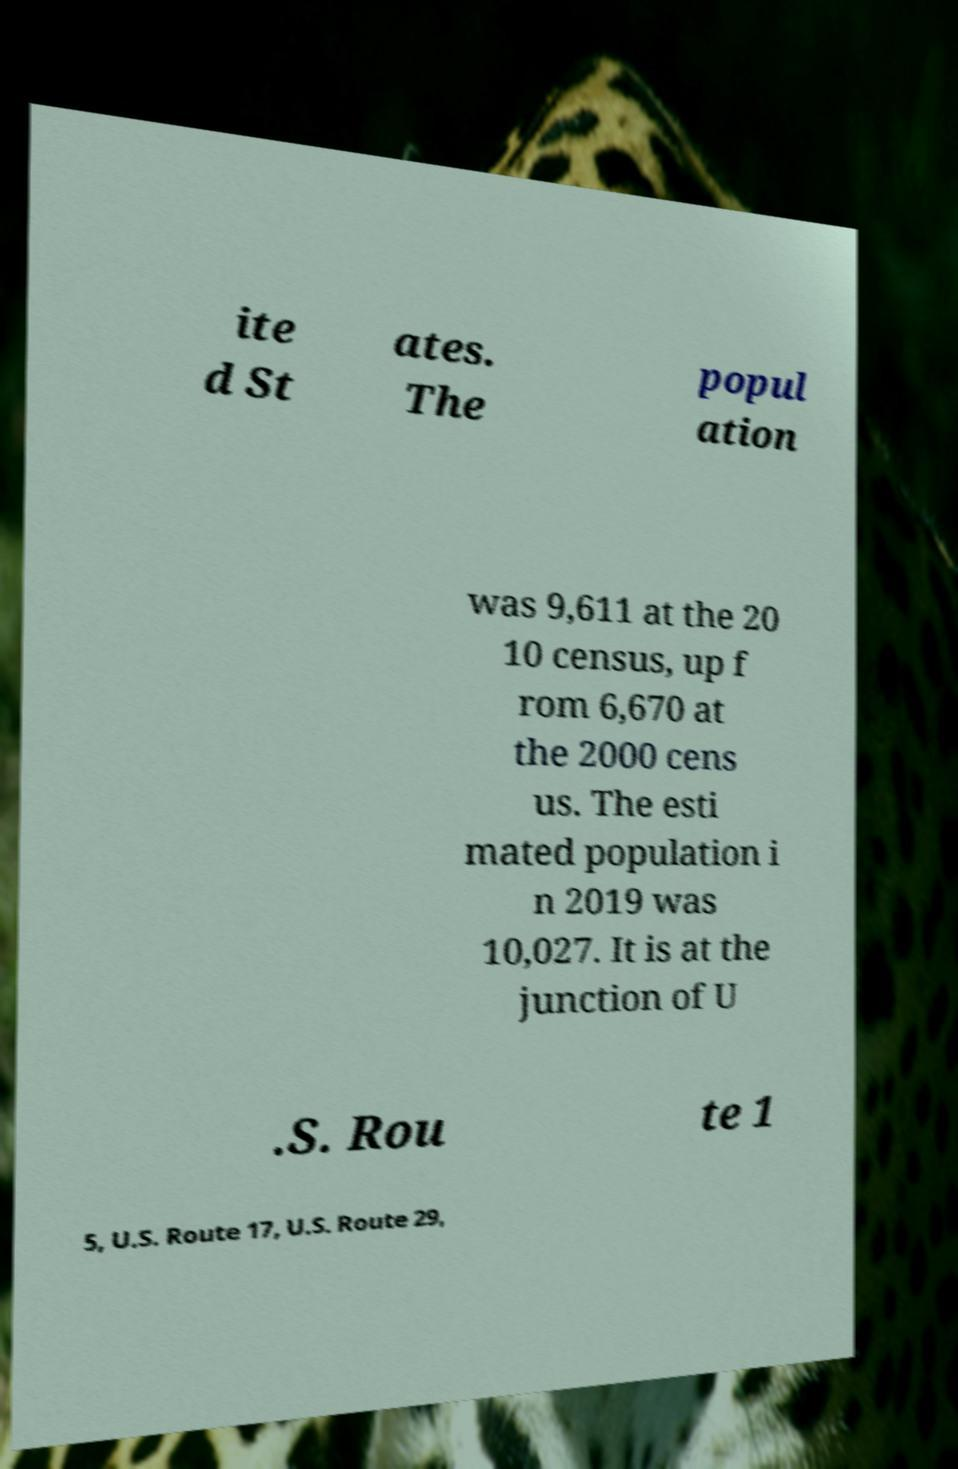Can you read and provide the text displayed in the image?This photo seems to have some interesting text. Can you extract and type it out for me? ite d St ates. The popul ation was 9,611 at the 20 10 census, up f rom 6,670 at the 2000 cens us. The esti mated population i n 2019 was 10,027. It is at the junction of U .S. Rou te 1 5, U.S. Route 17, U.S. Route 29, 